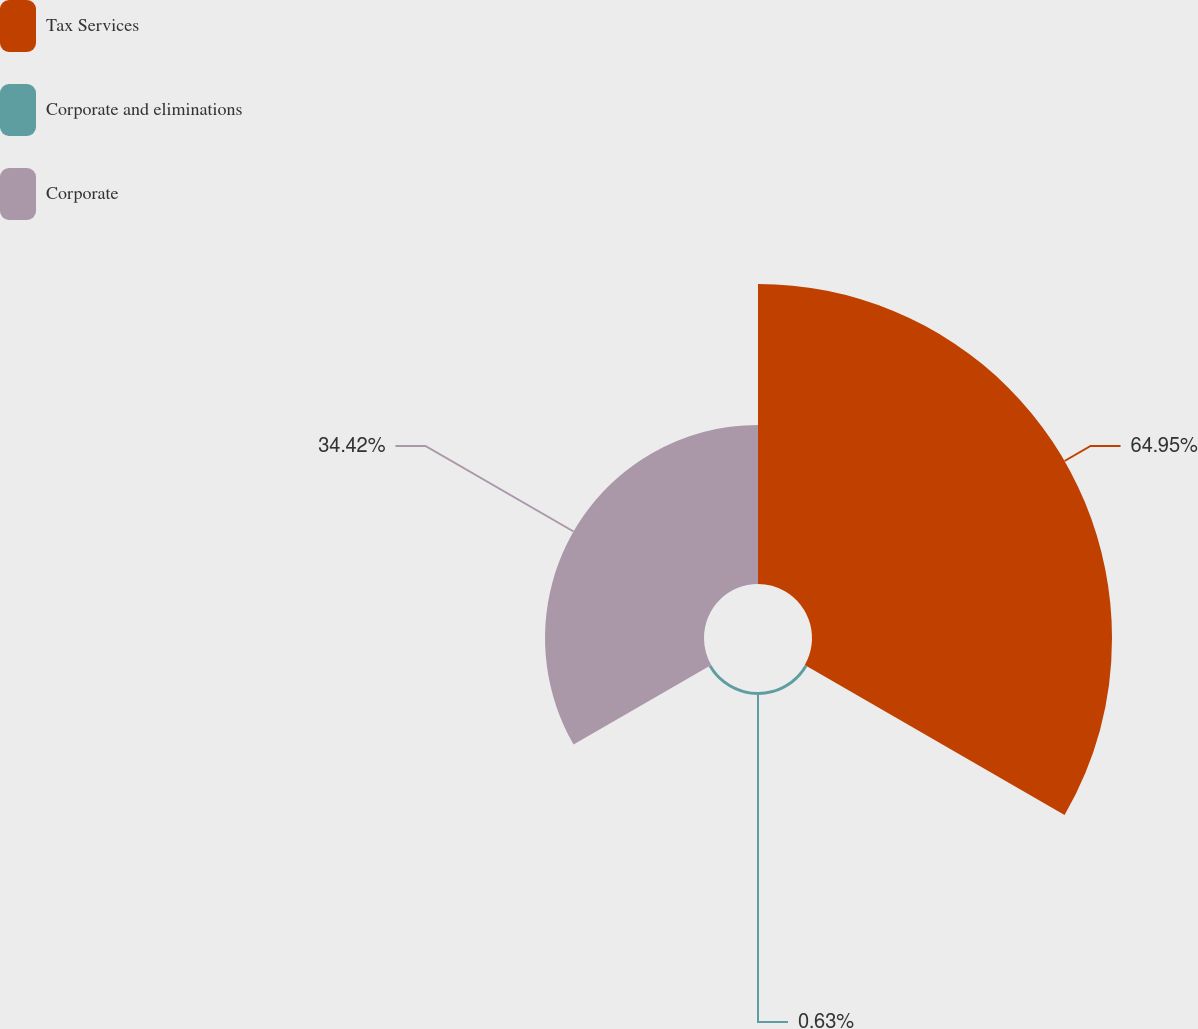<chart> <loc_0><loc_0><loc_500><loc_500><pie_chart><fcel>Tax Services<fcel>Corporate and eliminations<fcel>Corporate<nl><fcel>64.95%<fcel>0.63%<fcel>34.42%<nl></chart> 